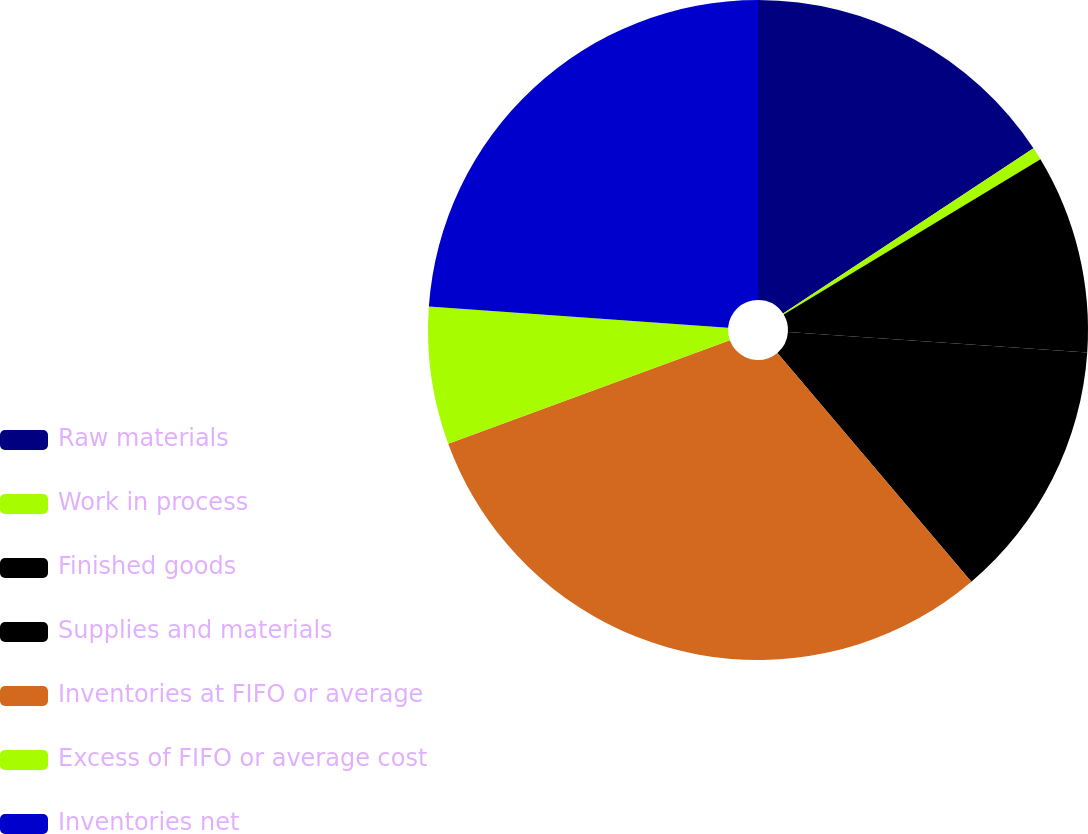Convert chart to OTSL. <chart><loc_0><loc_0><loc_500><loc_500><pie_chart><fcel>Raw materials<fcel>Work in process<fcel>Finished goods<fcel>Supplies and materials<fcel>Inventories at FIFO or average<fcel>Excess of FIFO or average cost<fcel>Inventories net<nl><fcel>15.72%<fcel>0.63%<fcel>9.73%<fcel>12.73%<fcel>30.59%<fcel>6.74%<fcel>23.86%<nl></chart> 